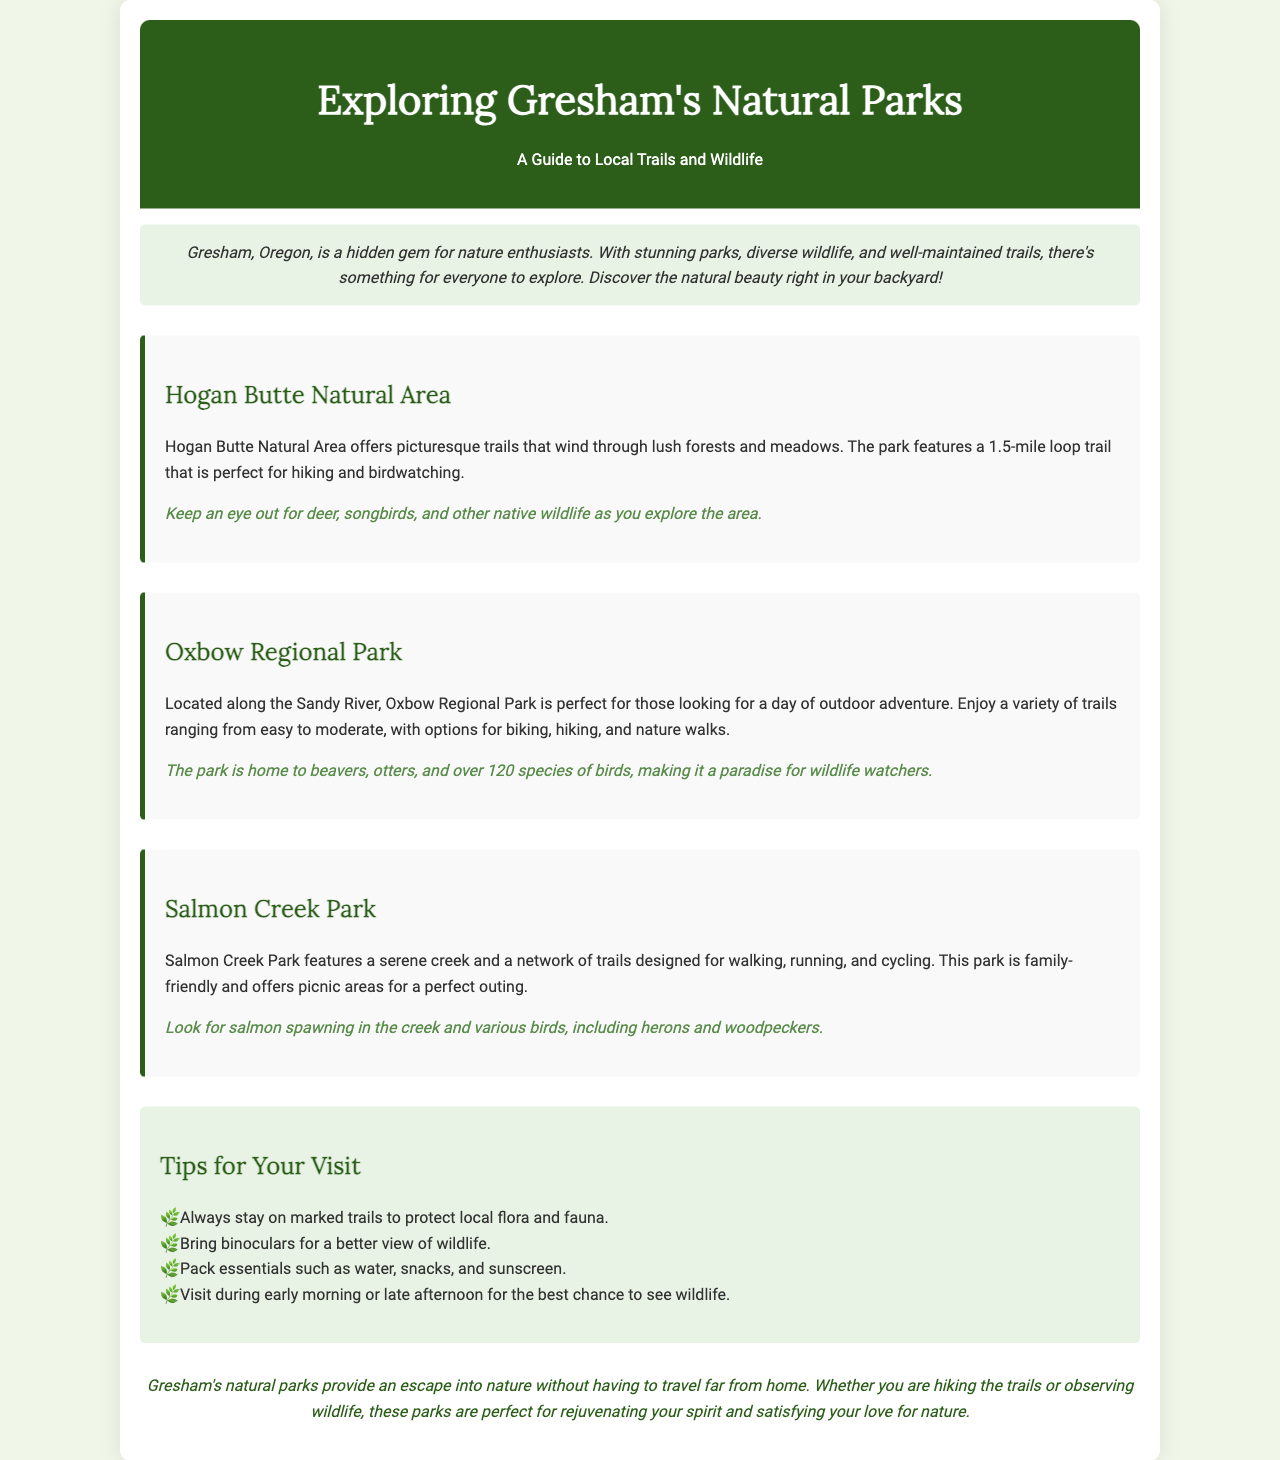What is the name of the first park mentioned? The first park mentioned in the brochure is specifically titled Hogan Butte Natural Area.
Answer: Hogan Butte Natural Area How long is the loop trail at Hogan Butte Natural Area? The brochure states that the loop trail is 1.5 miles long.
Answer: 1.5 miles What kind of wildlife can you see at Oxbow Regional Park? The wildlife mentioned includes beavers, otters, and over 120 species of birds.
Answer: beavers, otters, and over 120 species of birds Which park is described as family-friendly? The brochure states that Salmon Creek Park is designed to be family-friendly.
Answer: Salmon Creek Park What is one tip mentioned for visiting the parks? One of the tips provided is to bring binoculars for a better view of wildlife.
Answer: Bring binoculars Why is visiting during early morning or late afternoon suggested? The reasoning indicates that these times offer the best chance to see wildlife, which requires understanding both wildlife behavior and timing of visits.
Answer: best chance to see wildlife In what document type is the information presented? The information is presented in a brochure format, which is designed to inform and guide visitors to the parks.
Answer: brochure What additional activities can you do at Oxbow Regional Park besides hiking? The brochure mentions biking and nature walks as other activities available at Oxbow Regional Park.
Answer: biking and nature walks 